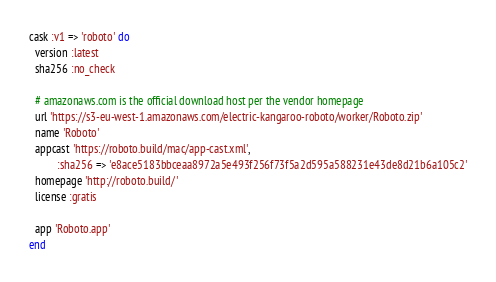<code> <loc_0><loc_0><loc_500><loc_500><_Ruby_>cask :v1 => 'roboto' do
  version :latest
  sha256 :no_check

  # amazonaws.com is the official download host per the vendor homepage
  url 'https://s3-eu-west-1.amazonaws.com/electric-kangaroo-roboto/worker/Roboto.zip'
  name 'Roboto'
  appcast 'https://roboto.build/mac/app-cast.xml',
          :sha256 => 'e8ace5183bbceaa8972a5e493f256f73f5a2d595a588231e43de8d21b6a105c2'
  homepage 'http://roboto.build/'
  license :gratis

  app 'Roboto.app'
end
</code> 